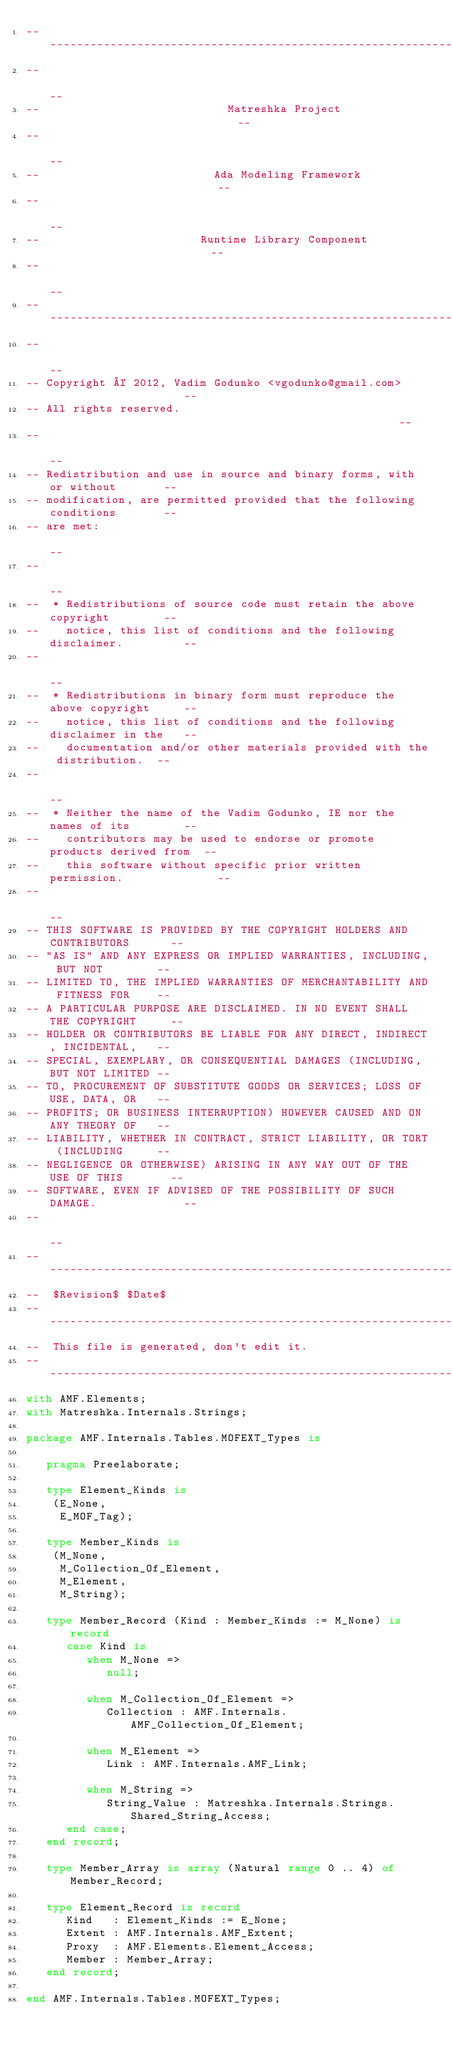<code> <loc_0><loc_0><loc_500><loc_500><_Ada_>------------------------------------------------------------------------------
--                                                                          --
--                            Matreshka Project                             --
--                                                                          --
--                          Ada Modeling Framework                          --
--                                                                          --
--                        Runtime Library Component                         --
--                                                                          --
------------------------------------------------------------------------------
--                                                                          --
-- Copyright © 2012, Vadim Godunko <vgodunko@gmail.com>                     --
-- All rights reserved.                                                     --
--                                                                          --
-- Redistribution and use in source and binary forms, with or without       --
-- modification, are permitted provided that the following conditions       --
-- are met:                                                                 --
--                                                                          --
--  * Redistributions of source code must retain the above copyright        --
--    notice, this list of conditions and the following disclaimer.         --
--                                                                          --
--  * Redistributions in binary form must reproduce the above copyright     --
--    notice, this list of conditions and the following disclaimer in the   --
--    documentation and/or other materials provided with the distribution.  --
--                                                                          --
--  * Neither the name of the Vadim Godunko, IE nor the names of its        --
--    contributors may be used to endorse or promote products derived from  --
--    this software without specific prior written permission.              --
--                                                                          --
-- THIS SOFTWARE IS PROVIDED BY THE COPYRIGHT HOLDERS AND CONTRIBUTORS      --
-- "AS IS" AND ANY EXPRESS OR IMPLIED WARRANTIES, INCLUDING, BUT NOT        --
-- LIMITED TO, THE IMPLIED WARRANTIES OF MERCHANTABILITY AND FITNESS FOR    --
-- A PARTICULAR PURPOSE ARE DISCLAIMED. IN NO EVENT SHALL THE COPYRIGHT     --
-- HOLDER OR CONTRIBUTORS BE LIABLE FOR ANY DIRECT, INDIRECT, INCIDENTAL,   --
-- SPECIAL, EXEMPLARY, OR CONSEQUENTIAL DAMAGES (INCLUDING, BUT NOT LIMITED --
-- TO, PROCUREMENT OF SUBSTITUTE GOODS OR SERVICES; LOSS OF USE, DATA, OR   --
-- PROFITS; OR BUSINESS INTERRUPTION) HOWEVER CAUSED AND ON ANY THEORY OF   --
-- LIABILITY, WHETHER IN CONTRACT, STRICT LIABILITY, OR TORT (INCLUDING     --
-- NEGLIGENCE OR OTHERWISE) ARISING IN ANY WAY OUT OF THE USE OF THIS       --
-- SOFTWARE, EVEN IF ADVISED OF THE POSSIBILITY OF SUCH DAMAGE.             --
--                                                                          --
------------------------------------------------------------------------------
--  $Revision$ $Date$
------------------------------------------------------------------------------
--  This file is generated, don't edit it.
------------------------------------------------------------------------------
with AMF.Elements;
with Matreshka.Internals.Strings;

package AMF.Internals.Tables.MOFEXT_Types is

   pragma Preelaborate;

   type Element_Kinds is
    (E_None,
     E_MOF_Tag);

   type Member_Kinds is
    (M_None,
     M_Collection_Of_Element,
     M_Element,
     M_String);

   type Member_Record (Kind : Member_Kinds := M_None) is record
      case Kind is
         when M_None =>
            null;

         when M_Collection_Of_Element =>
            Collection : AMF.Internals.AMF_Collection_Of_Element;

         when M_Element =>
            Link : AMF.Internals.AMF_Link;

         when M_String =>
            String_Value : Matreshka.Internals.Strings.Shared_String_Access;
      end case;
   end record;

   type Member_Array is array (Natural range 0 .. 4) of Member_Record;

   type Element_Record is record
      Kind   : Element_Kinds := E_None;
      Extent : AMF.Internals.AMF_Extent;
      Proxy  : AMF.Elements.Element_Access;
      Member : Member_Array;
   end record;

end AMF.Internals.Tables.MOFEXT_Types;
</code> 